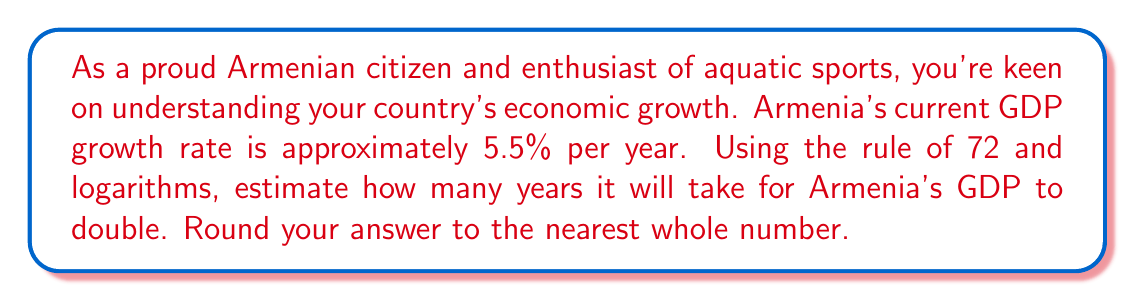What is the answer to this math problem? To solve this problem, we'll use the rule of 72 and verify it using logarithms.

1) The rule of 72 states that for small growth rates, the time for a quantity to double is approximately:

   $$ T \approx \frac{72}{r} $$

   where $T$ is the time to double and $r$ is the growth rate as a percentage.

2) For Armenia's growth rate of 5.5%:

   $$ T \approx \frac{72}{5.5} \approx 13.09 \text{ years} $$

3) To verify this using logarithms, we can use the compound interest formula:

   $$ A = P(1 + r)^t $$

   where $A$ is the final amount, $P$ is the initial amount, $r$ is the growth rate (as a decimal), and $t$ is time.

4) For doubling, $A = 2P$. Substituting and taking logarithms:

   $$ 2P = P(1 + 0.055)^t $$
   $$ 2 = (1.055)^t $$
   $$ \log 2 = t \log 1.055 $$

5) Solving for $t$:

   $$ t = \frac{\log 2}{\log 1.055} \approx 12.94 \text{ years} $$

6) This confirms that our rule of 72 approximation is quite accurate.

Rounding to the nearest whole number, we get 13 years.
Answer: 13 years 